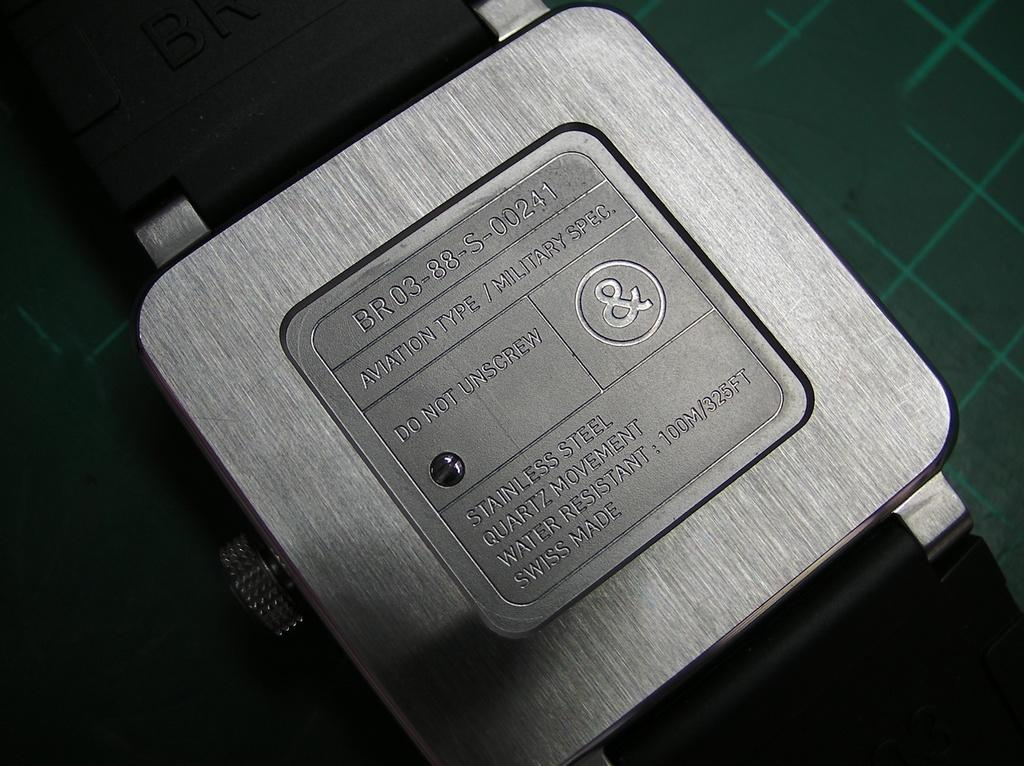<image>
Render a clear and concise summary of the photo. The back of a stainless steel quartz movement watch 